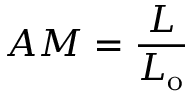<formula> <loc_0><loc_0><loc_500><loc_500>A M = { \frac { L } { L _ { o } } }</formula> 